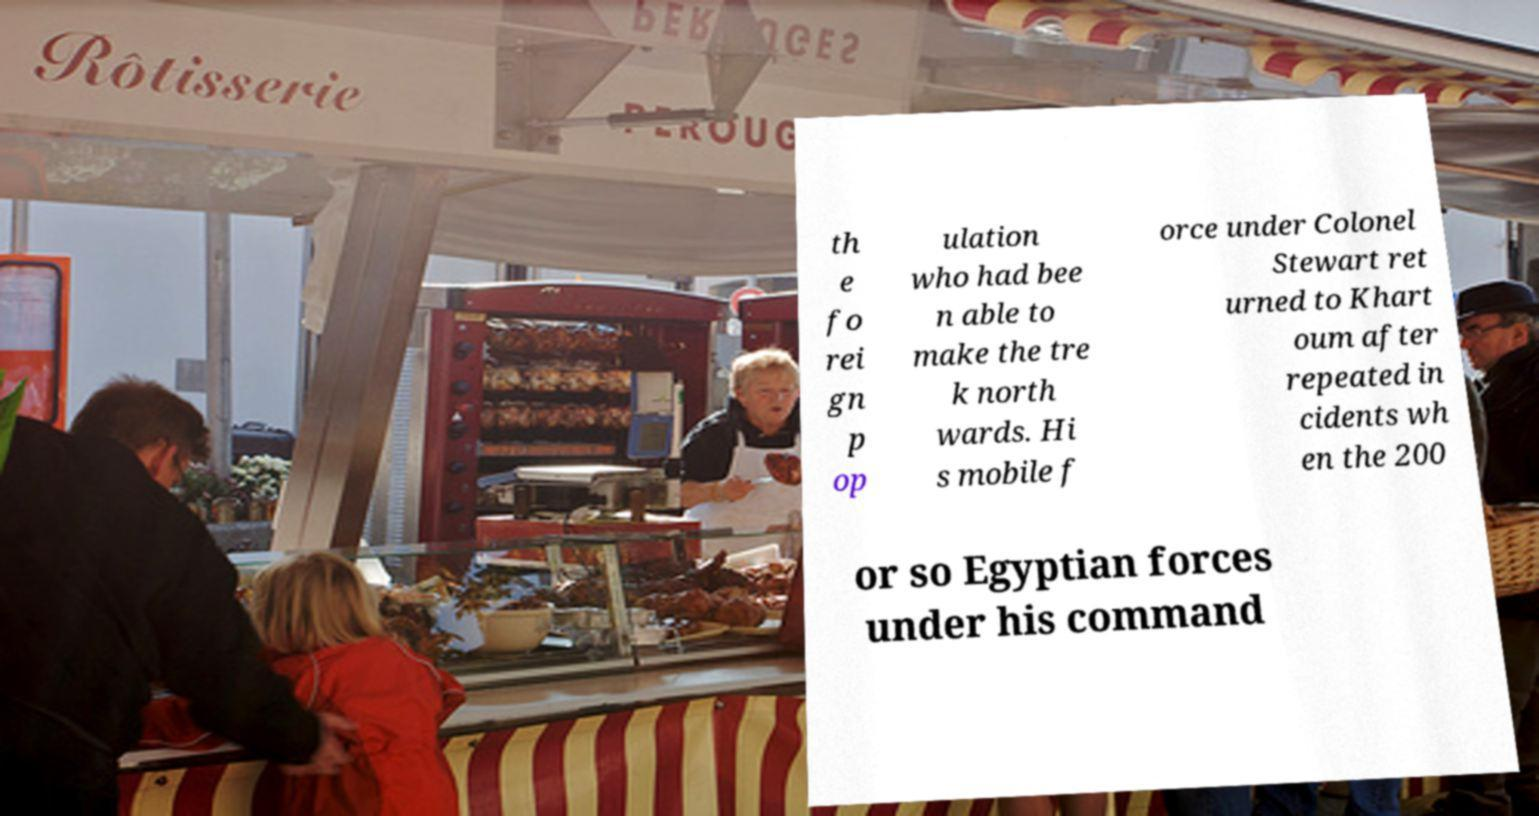Please identify and transcribe the text found in this image. th e fo rei gn p op ulation who had bee n able to make the tre k north wards. Hi s mobile f orce under Colonel Stewart ret urned to Khart oum after repeated in cidents wh en the 200 or so Egyptian forces under his command 